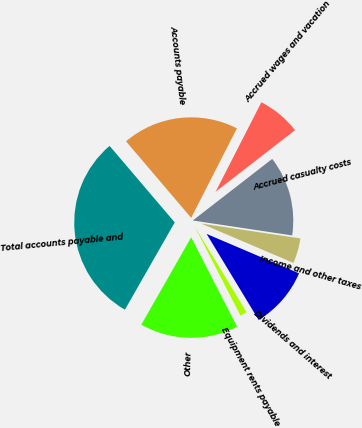Convert chart. <chart><loc_0><loc_0><loc_500><loc_500><pie_chart><fcel>Accounts payable<fcel>Accrued wages and vacation<fcel>Accrued casualty costs<fcel>Income and other taxes<fcel>Dividends and interest<fcel>Equipment rents payable<fcel>Other<fcel>Total accounts payable and<nl><fcel>18.75%<fcel>6.98%<fcel>12.87%<fcel>4.04%<fcel>9.93%<fcel>1.1%<fcel>15.81%<fcel>30.52%<nl></chart> 